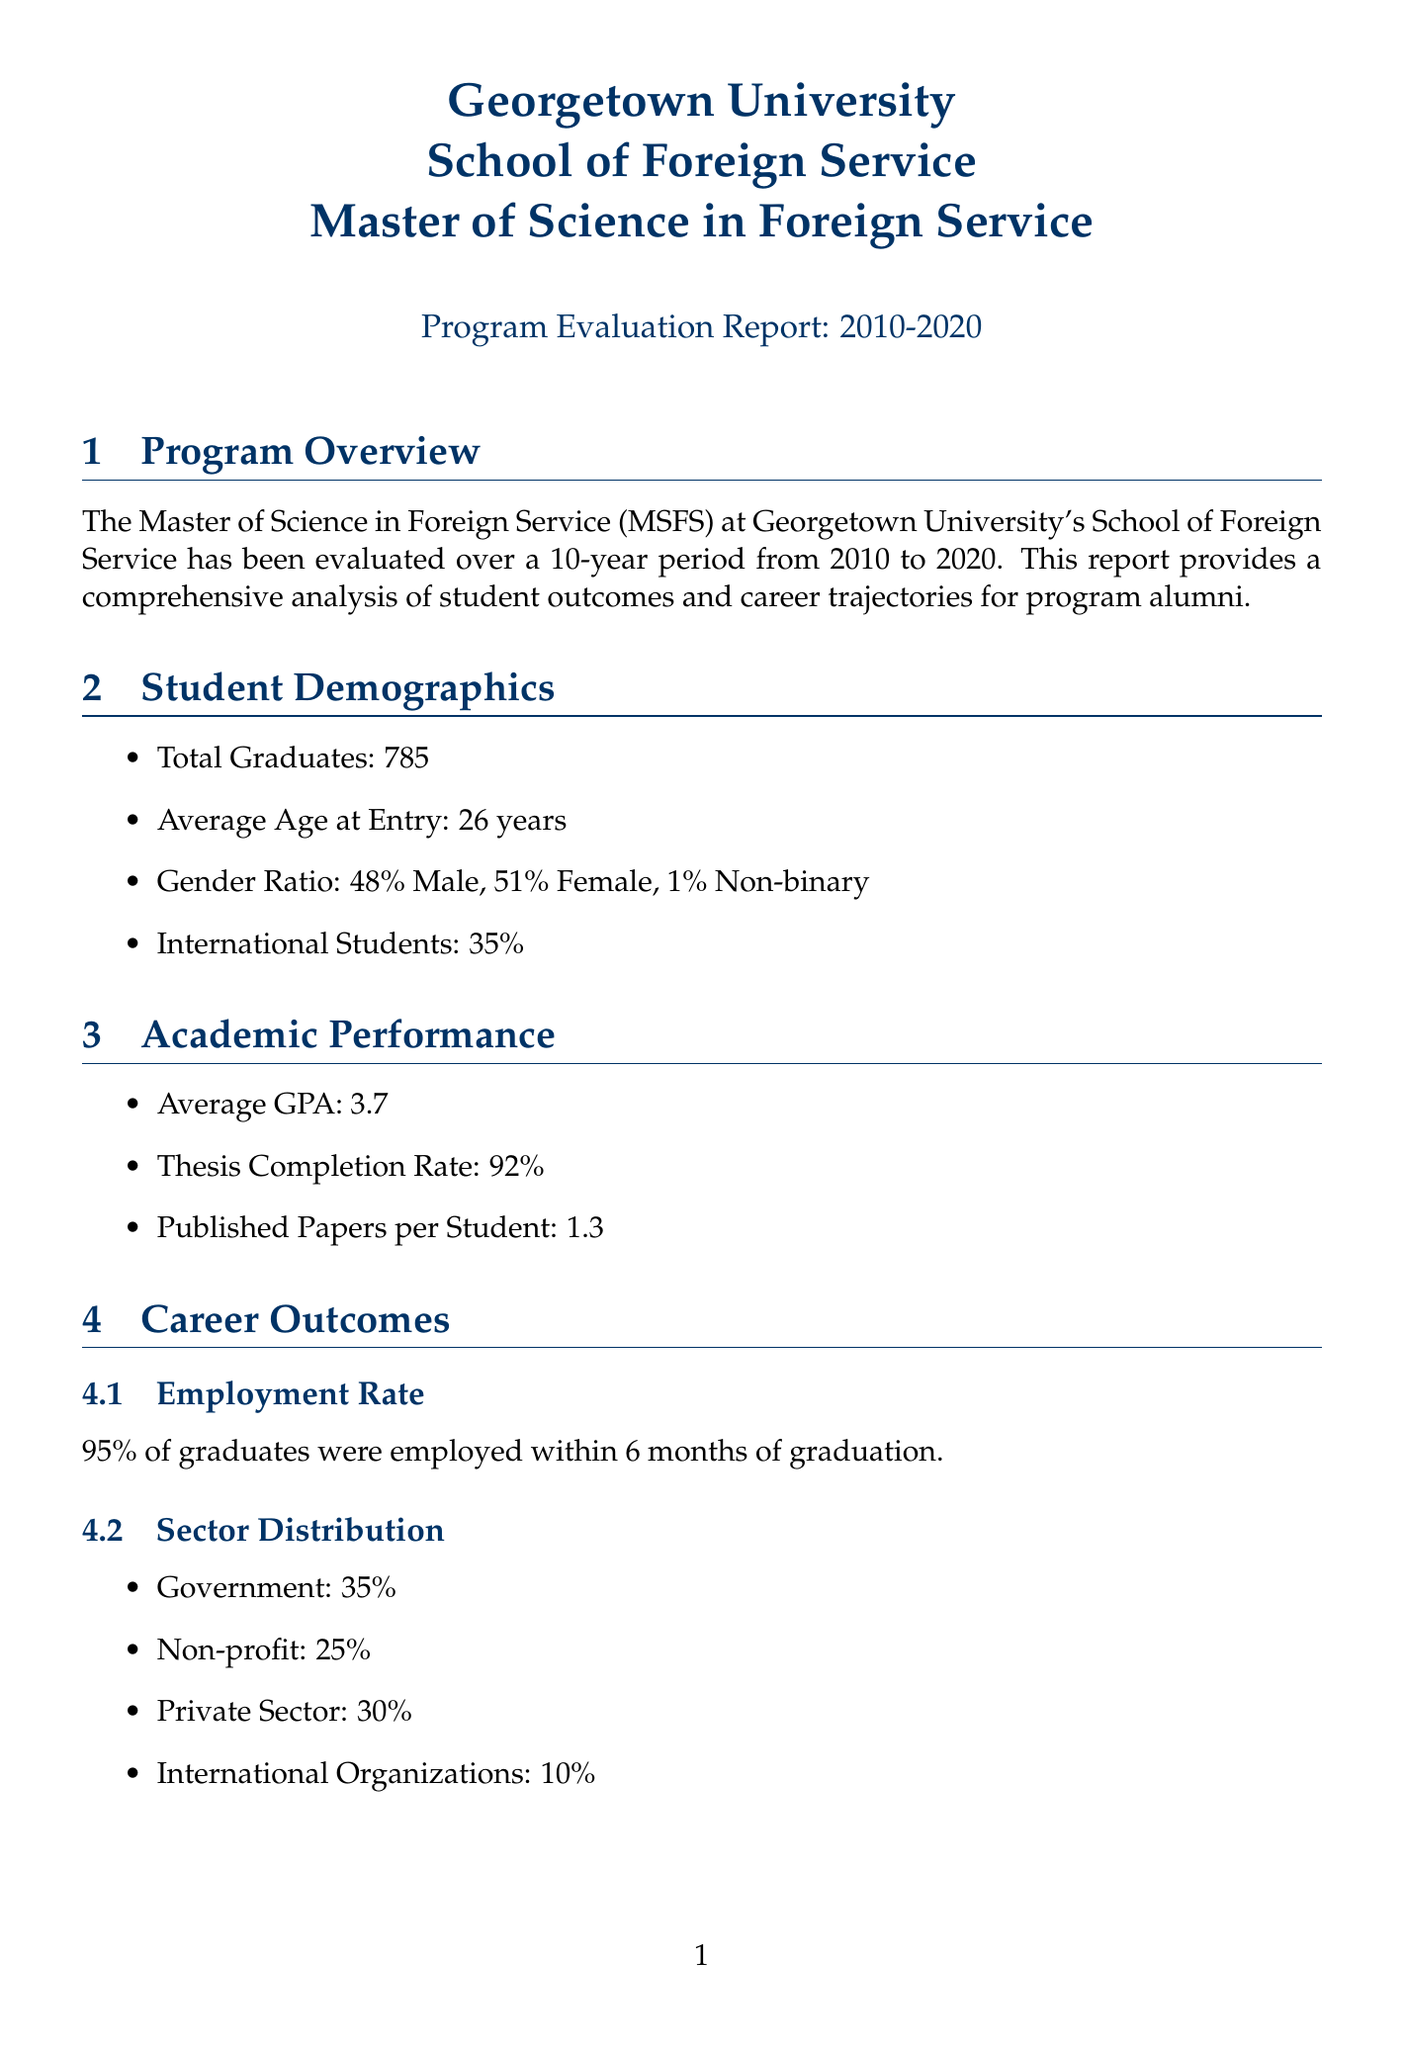What is the total number of graduates? The total number of graduates is stated in the document under student demographics as 785.
Answer: 785 What is the average starting salary for graduates? The average starting salary is provided in the career outcomes section as $72,000.
Answer: $72,000 What percentage of graduates work in the government sector? The document mentions that 35% of graduates work in the government sector as part of the sector distribution.
Answer: 35% How many Fulbright Scholarships were awarded to alumni? The number of Fulbright Scholarships awarded to alumni is noted as 28 in the alumni achievements section.
Answer: 28 What is the average GPA of the graduates? The average GPA is specified in the academic performance section as 3.7.
Answer: 3.7 What is the employment rate within six months after graduation? The employment rate is indicated in the career outcomes section as 95%.
Answer: 95% Which year did the Climate Diplomacy concentration launch? The document states that the Climate Diplomacy concentration was launched in 2019 in the curriculum changes section.
Answer: 2019 What percentage of alumni hold an advanced degree? The document indicates the percentage of alumni who hold advanced degrees as follows: PhD 15%, Law Degree 8%, MBA 12%, totalling 35%.
Answer: 35% What is the overall satisfaction rate reported by alumni? The overall satisfaction rate is mentioned in the alumni feedback section as 89%.
Answer: 89% 